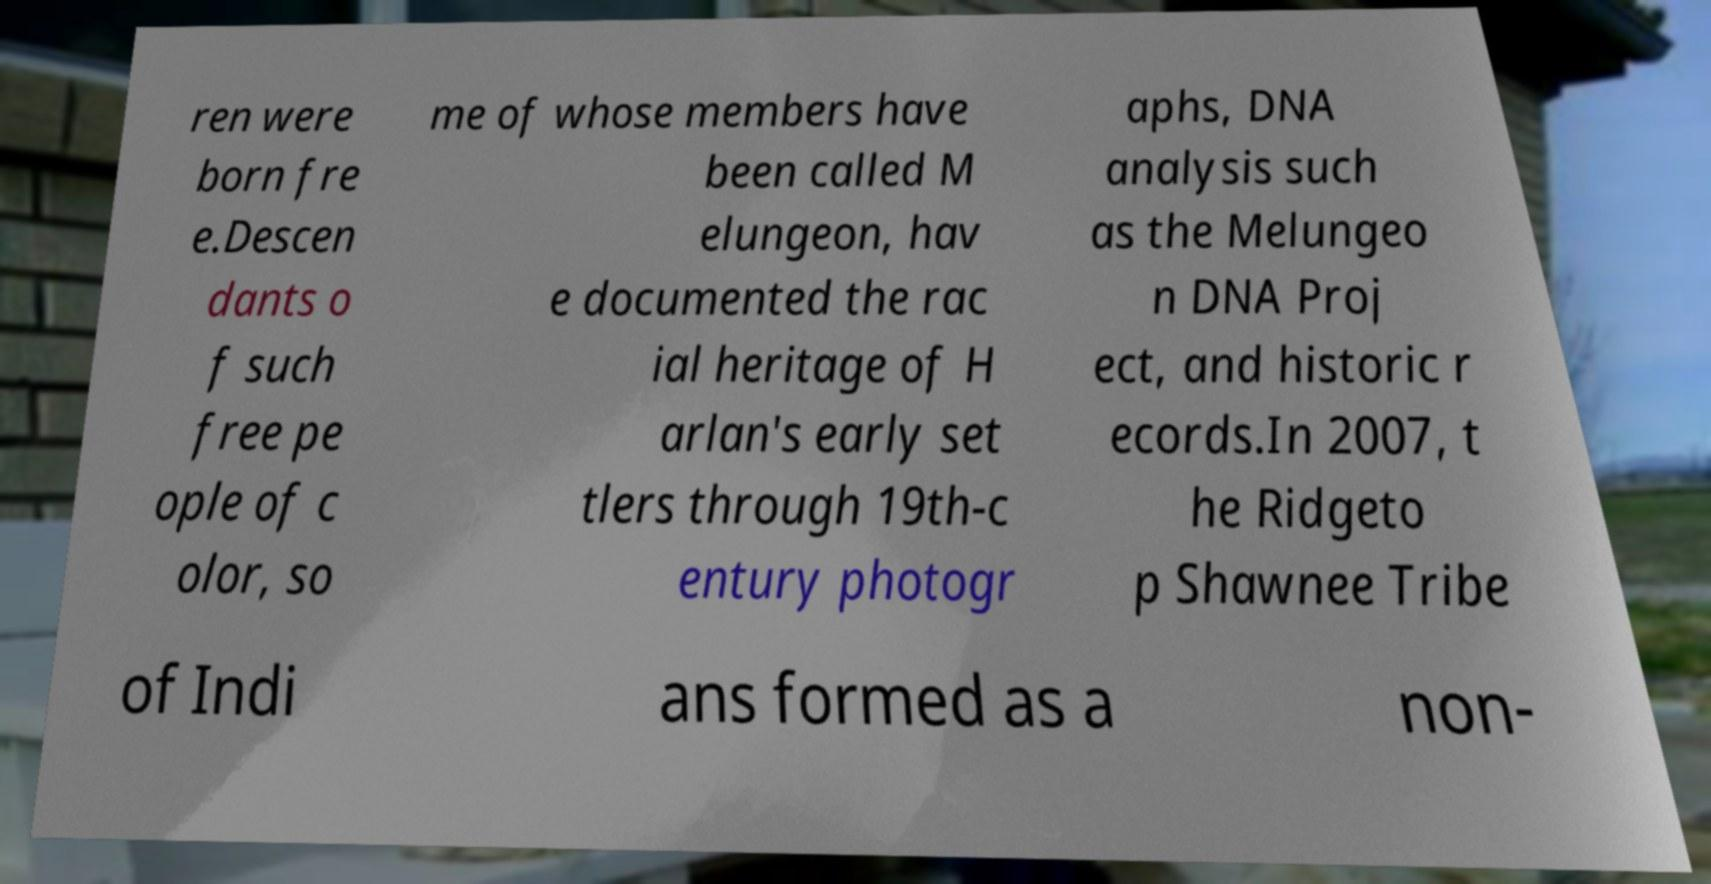Could you extract and type out the text from this image? ren were born fre e.Descen dants o f such free pe ople of c olor, so me of whose members have been called M elungeon, hav e documented the rac ial heritage of H arlan's early set tlers through 19th-c entury photogr aphs, DNA analysis such as the Melungeo n DNA Proj ect, and historic r ecords.In 2007, t he Ridgeto p Shawnee Tribe of Indi ans formed as a non- 